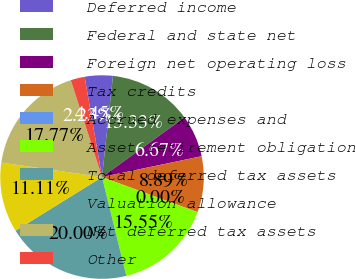Convert chart to OTSL. <chart><loc_0><loc_0><loc_500><loc_500><pie_chart><fcel>Deferred income<fcel>Federal and state net<fcel>Foreign net operating loss<fcel>Tax credits<fcel>Accrued expenses and<fcel>Asset retirement obligation<fcel>Total deferred tax assets<fcel>Valuation allowance<fcel>Net deferred tax assets<fcel>Other<nl><fcel>4.45%<fcel>13.33%<fcel>6.67%<fcel>8.89%<fcel>0.0%<fcel>15.55%<fcel>20.0%<fcel>11.11%<fcel>17.77%<fcel>2.23%<nl></chart> 